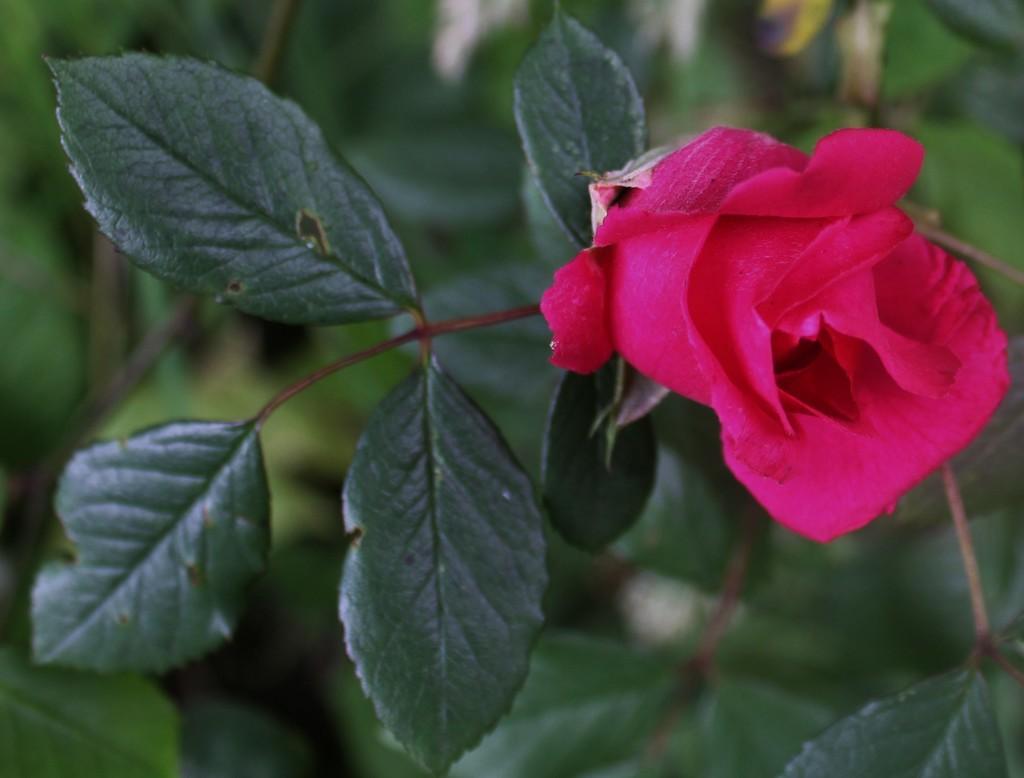Please provide a concise description of this image. In this picture we can see a flower, leaves and stems. Background is blurry. 